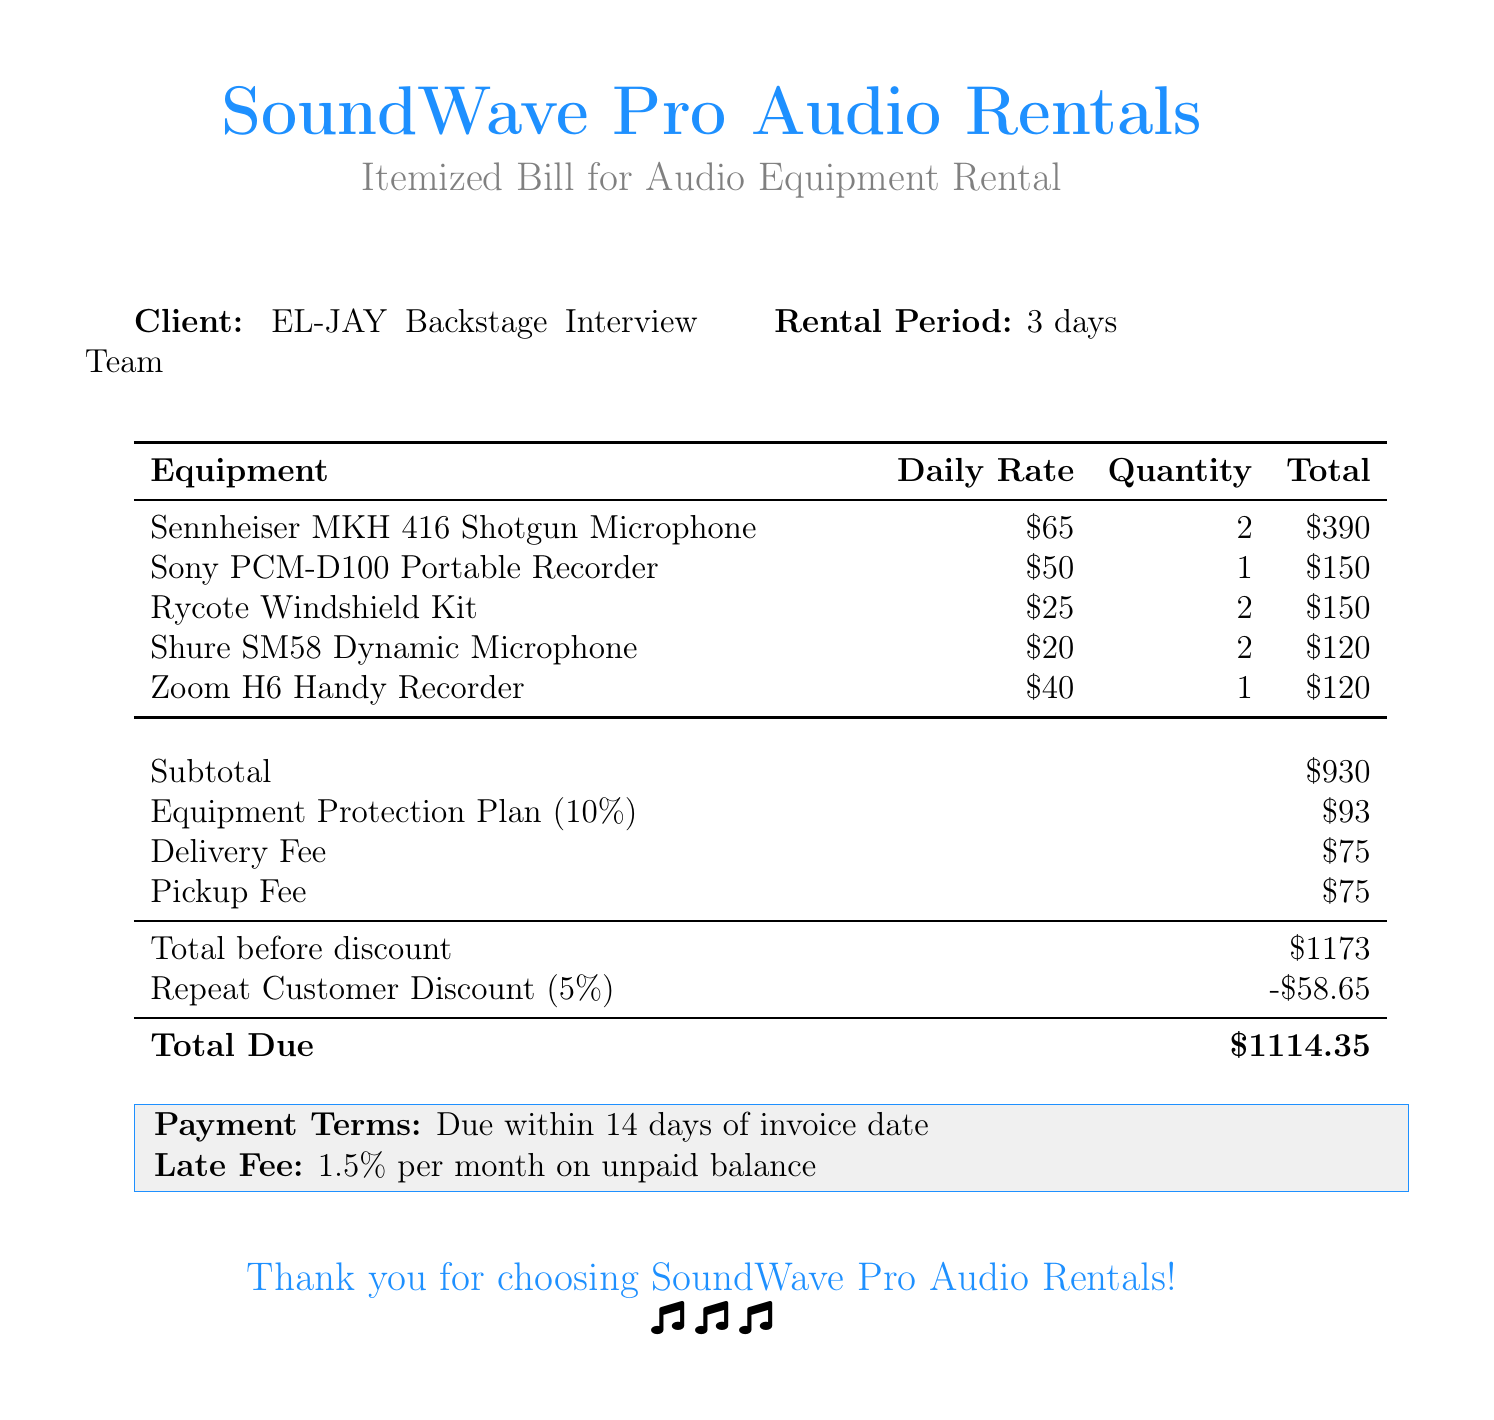What is the rental period? The rental period is specified in the document under 'Rental Period' as 3 days.
Answer: 3 days What is the daily rate for the Sennheiser MKH 416 Shotgun Microphone? The daily rate for the Sennheiser MKH 416 Shotgun Microphone is listed in the table of equipment rental costs.
Answer: $65 How much is the delivery fee? The delivery fee is stated in the billing summary section of the document.
Answer: $75 What is the total due after the discount? The total due is the final amount calculated after applying all fees and discounts, found at the bottom of the billing summary.
Answer: $1114.35 What percent is the Equipment Protection Plan? The Equipment Protection Plan percentage is mentioned in the subtotal section.
Answer: 10% What is the quantity of the Sony PCM-D100 Portable Recorder rented? The quantity is listed in the equipment table alongside its daily rate.
Answer: 1 What discount was applied for being a repeat customer? The repeat customer discount is shown in the billing summary section, indicating its amount.
Answer: $58.65 What is the late fee percentage per month on unpaid balance? The late fee percentage is specified under the payment terms section of the document.
Answer: 1.5% Who is the client in this bill? The client is identified at the beginning of the document under the client section.
Answer: EL-JAY Backstage Interview Team 